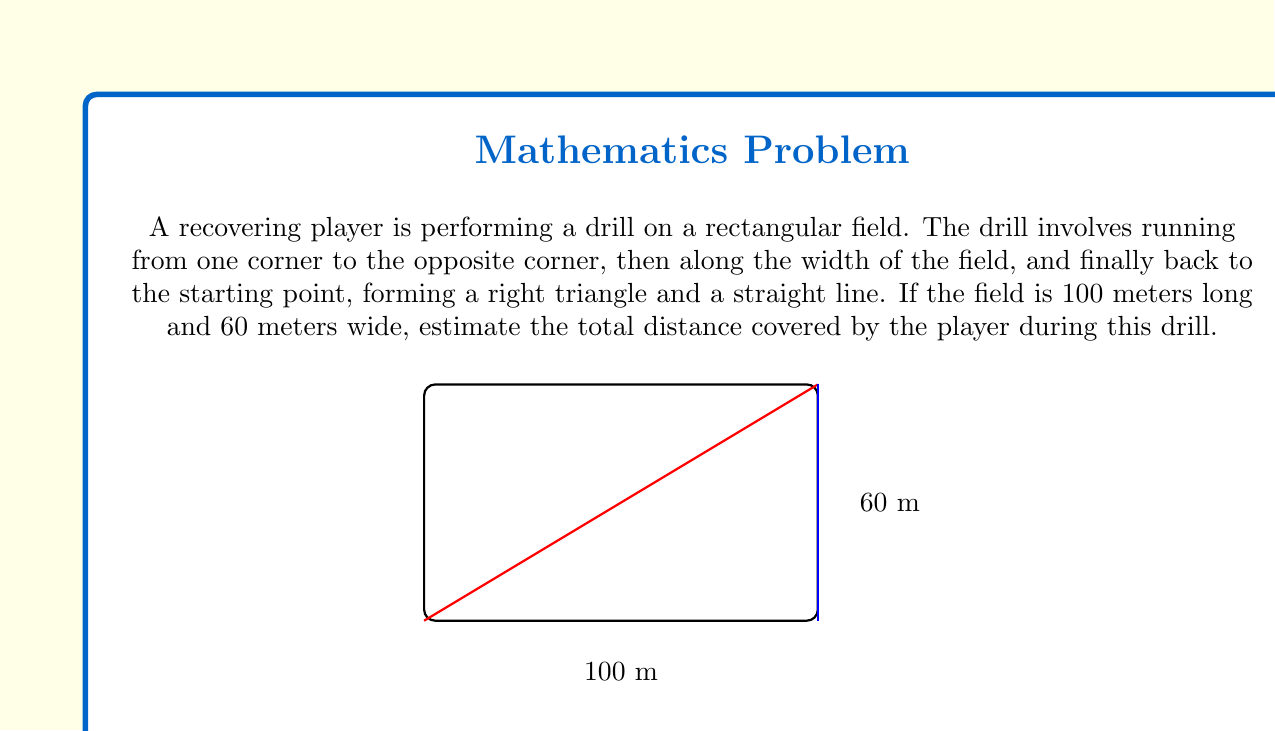Teach me how to tackle this problem. Let's approach this step-by-step:

1) First, we need to calculate the distance of the diagonal run (from one corner to the opposite corner). This forms the hypotenuse of a right triangle.

2) We can use the Pythagorean theorem to calculate this distance:
   $$a^2 + b^2 = c^2$$
   Where $a = 100$ m, $b = 60$ m, and $c$ is the diagonal distance.

3) Plugging in the values:
   $$100^2 + 60^2 = c^2$$
   $$10000 + 3600 = c^2$$
   $$13600 = c^2$$

4) Taking the square root of both sides:
   $$c = \sqrt{13600} \approx 116.62 \text{ m}$$

5) The second part of the drill is running along the width of the field, which is 60 m.

6) The final part is running back to the starting point, which is 100 m (the length of the field).

7) To get the total distance, we sum up all three parts:
   $$\text{Total Distance} = 116.62 + 60 + 100 = 276.62 \text{ m}$$

8) Rounding to the nearest meter for a reasonable estimate:
   $$\text{Total Distance} \approx 277 \text{ m}$$
Answer: 277 m 